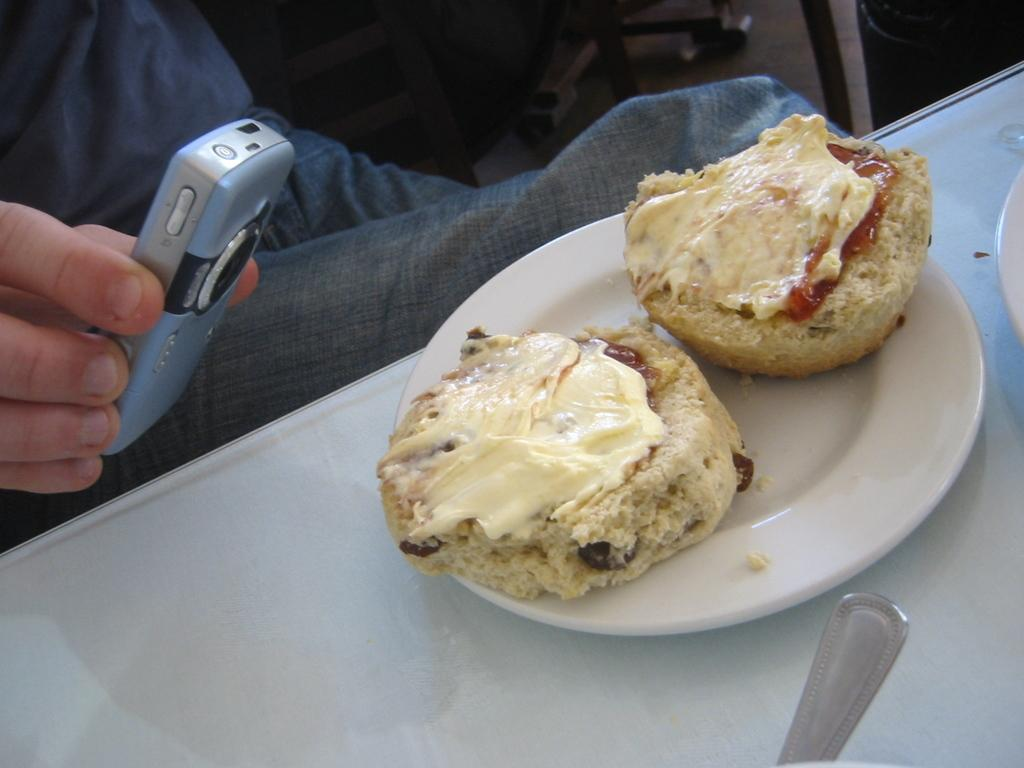What is on the table in the image? There is a plate with food on a table. What is the person in the image doing? The person is holding a mobile. How many geese are flying in the image? There are no geese present in the image. What type of wing is attached to the person's back in the image? There is no wing present in the image; the person is holding a mobile. 